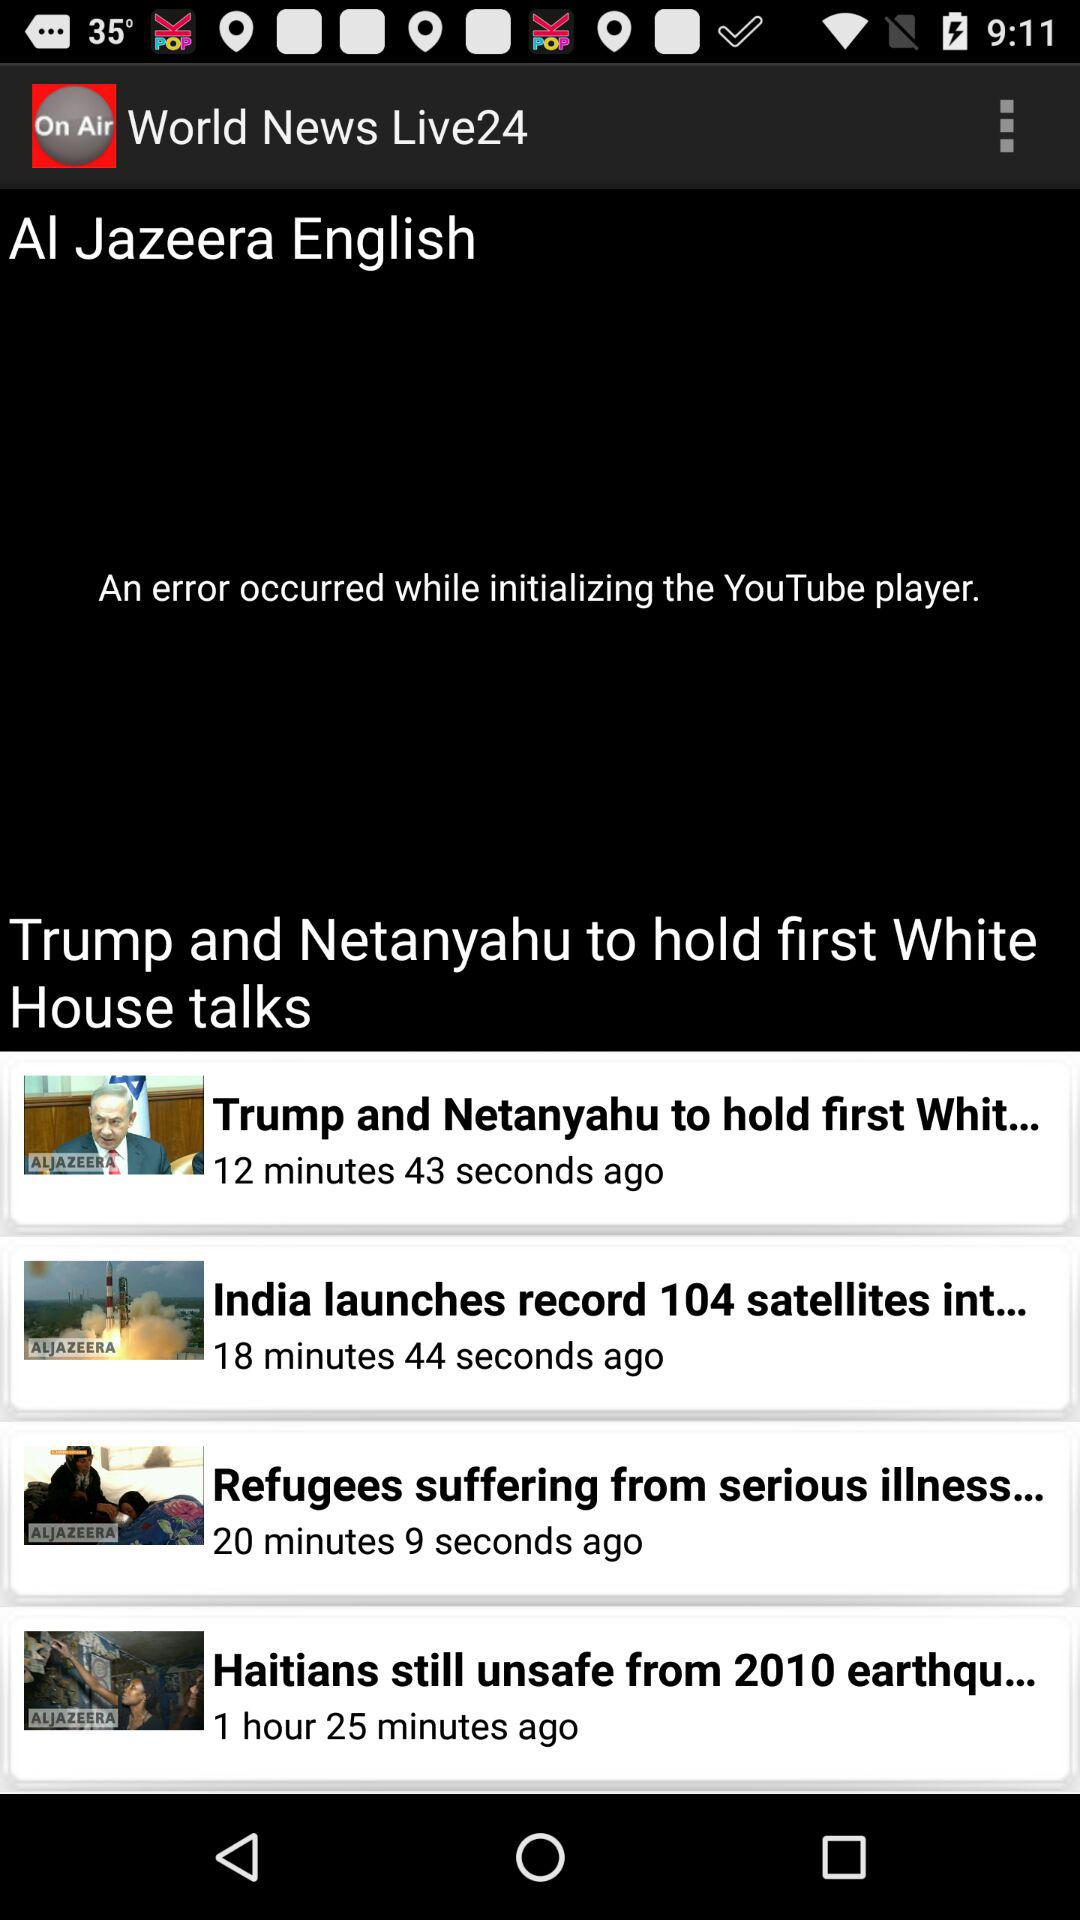Who held the first White House talks? The first White House talks were held by Trump and Netanyahu. 